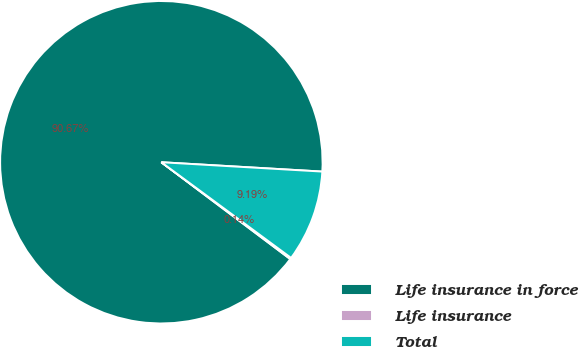Convert chart to OTSL. <chart><loc_0><loc_0><loc_500><loc_500><pie_chart><fcel>Life insurance in force<fcel>Life insurance<fcel>Total<nl><fcel>90.67%<fcel>0.14%<fcel>9.19%<nl></chart> 